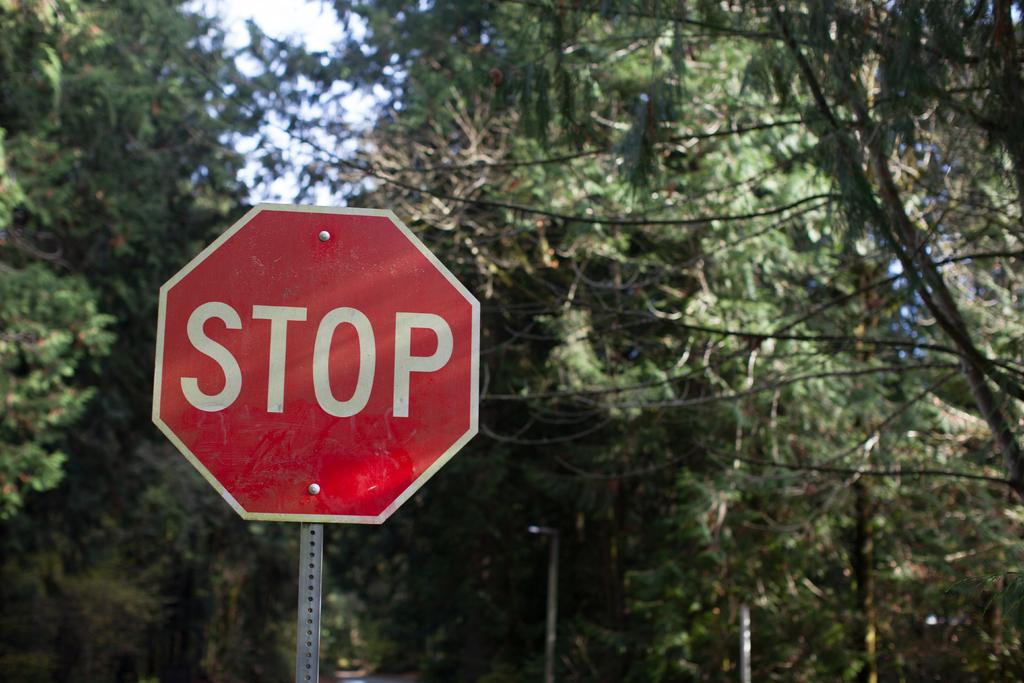<image>
Share a concise interpretation of the image provided. An American stop sign with a backdrop of trees. 